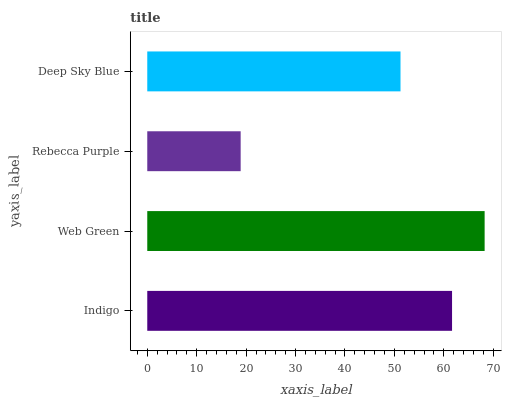Is Rebecca Purple the minimum?
Answer yes or no. Yes. Is Web Green the maximum?
Answer yes or no. Yes. Is Web Green the minimum?
Answer yes or no. No. Is Rebecca Purple the maximum?
Answer yes or no. No. Is Web Green greater than Rebecca Purple?
Answer yes or no. Yes. Is Rebecca Purple less than Web Green?
Answer yes or no. Yes. Is Rebecca Purple greater than Web Green?
Answer yes or no. No. Is Web Green less than Rebecca Purple?
Answer yes or no. No. Is Indigo the high median?
Answer yes or no. Yes. Is Deep Sky Blue the low median?
Answer yes or no. Yes. Is Web Green the high median?
Answer yes or no. No. Is Rebecca Purple the low median?
Answer yes or no. No. 